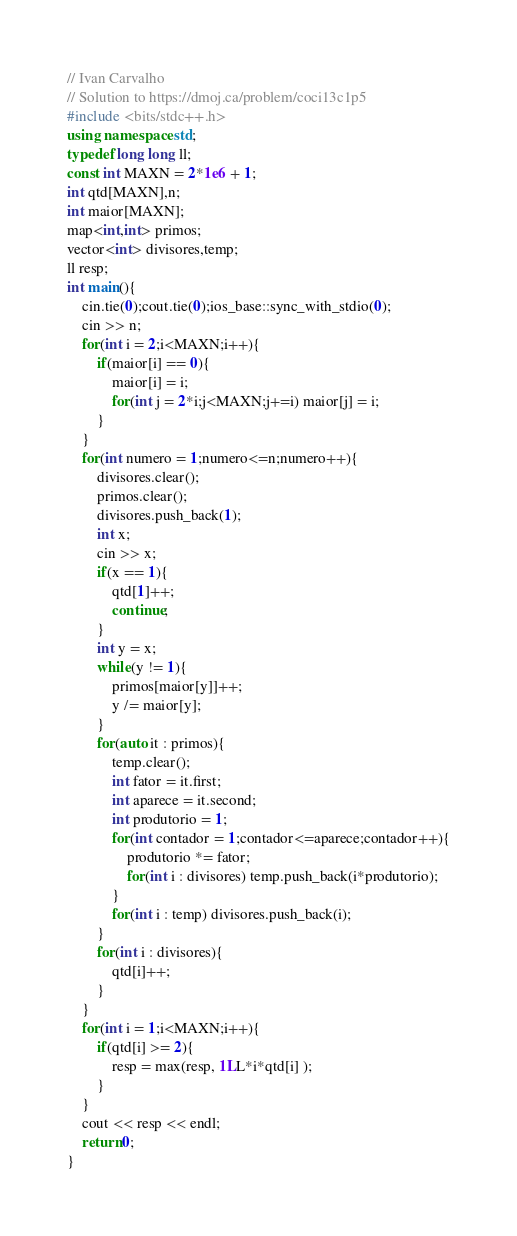<code> <loc_0><loc_0><loc_500><loc_500><_C++_>// Ivan Carvalho
// Solution to https://dmoj.ca/problem/coci13c1p5
#include <bits/stdc++.h>
using namespace std;
typedef long long ll;
const int MAXN = 2*1e6 + 1;
int qtd[MAXN],n;
int maior[MAXN];
map<int,int> primos;
vector<int> divisores,temp;
ll resp;
int main(){
	cin.tie(0);cout.tie(0);ios_base::sync_with_stdio(0);
	cin >> n;
	for(int i = 2;i<MAXN;i++){
		if(maior[i] == 0){
			maior[i] = i;
			for(int j = 2*i;j<MAXN;j+=i) maior[j] = i;
		}
	}
	for(int numero = 1;numero<=n;numero++){
		divisores.clear();
		primos.clear();
		divisores.push_back(1);
		int x;
		cin >> x;
		if(x == 1){
			qtd[1]++;
			continue;
		}
		int y = x;
		while(y != 1){
			primos[maior[y]]++;
			y /= maior[y];
		}
		for(auto it : primos){
			temp.clear();
			int fator = it.first;
			int aparece = it.second;
			int produtorio = 1;
			for(int contador = 1;contador<=aparece;contador++){
				produtorio *= fator;
				for(int i : divisores) temp.push_back(i*produtorio);
			}
			for(int i : temp) divisores.push_back(i);
		}
		for(int i : divisores){
			qtd[i]++;
		}
	}
	for(int i = 1;i<MAXN;i++){
		if(qtd[i] >= 2){
			resp = max(resp, 1LL*i*qtd[i] );
		}
	}
	cout << resp << endl;
	return 0;
}</code> 